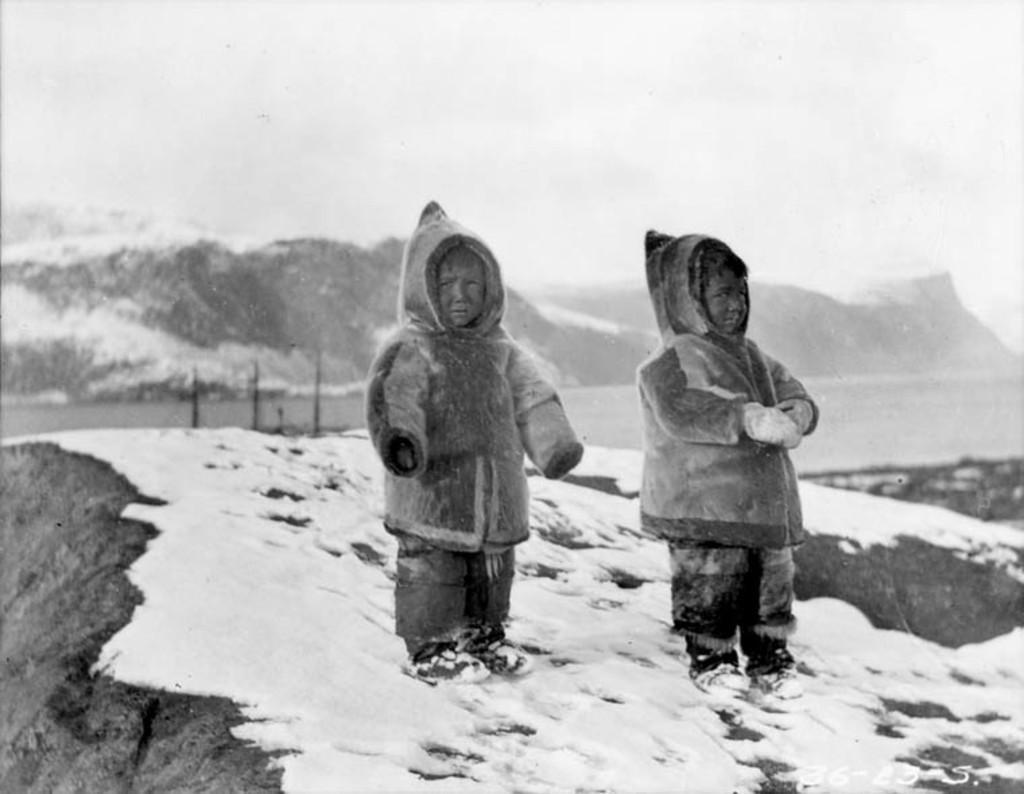Can you describe this image briefly? In the middle of this image, there are two children, wearing sweaters and standing on the snow surface of a hill. In the background, there is water, there are mountains and there are clouds in the sky. 